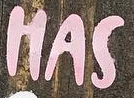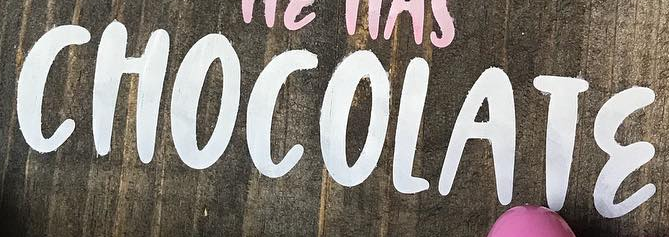Identify the words shown in these images in order, separated by a semicolon. HAS; CHOCOLATƐ 